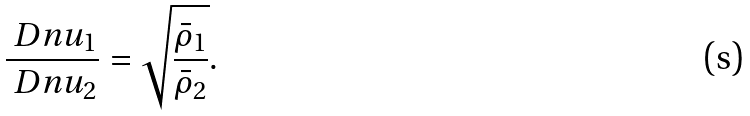Convert formula to latex. <formula><loc_0><loc_0><loc_500><loc_500>\frac { \ D n u _ { 1 } } { \ D n u _ { 2 } } = \sqrt { \frac { \bar { \rho } _ { 1 } } { \bar { \rho } _ { 2 } } } .</formula> 